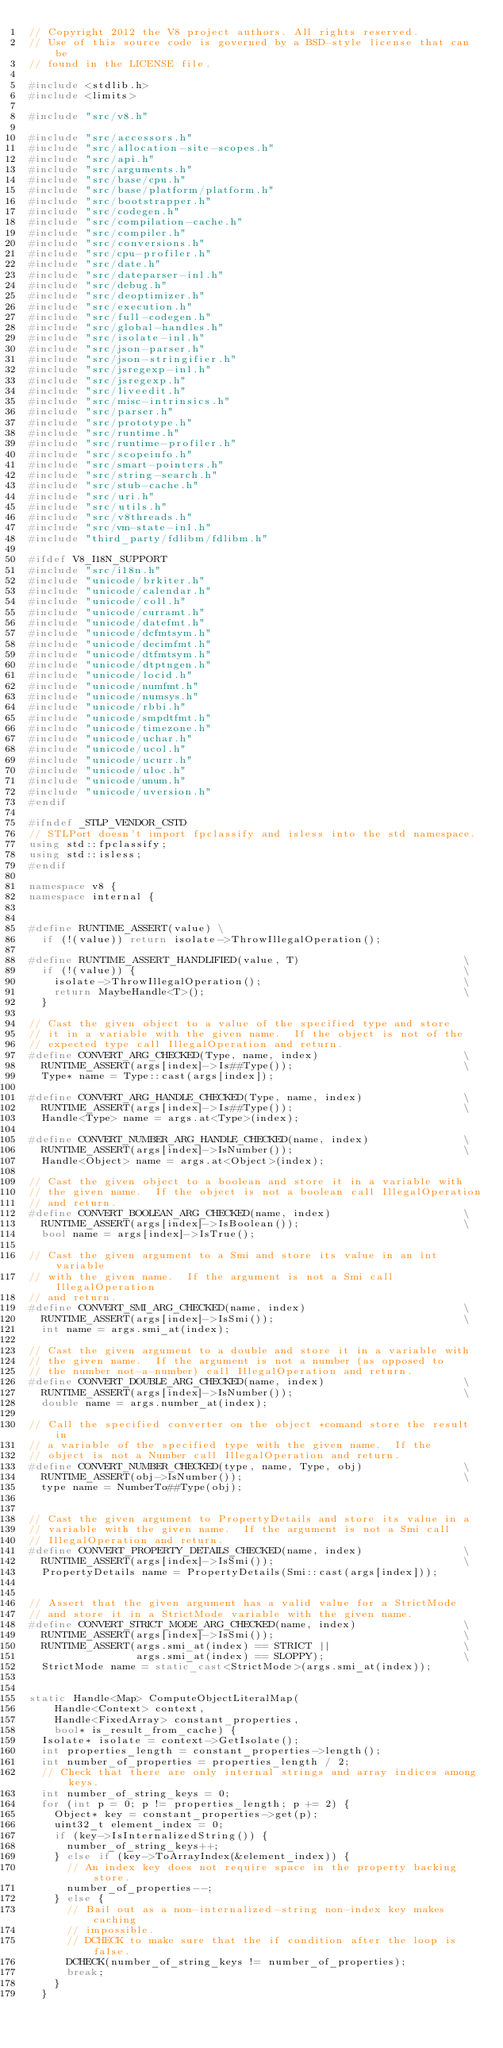<code> <loc_0><loc_0><loc_500><loc_500><_C++_>// Copyright 2012 the V8 project authors. All rights reserved.
// Use of this source code is governed by a BSD-style license that can be
// found in the LICENSE file.

#include <stdlib.h>
#include <limits>

#include "src/v8.h"

#include "src/accessors.h"
#include "src/allocation-site-scopes.h"
#include "src/api.h"
#include "src/arguments.h"
#include "src/base/cpu.h"
#include "src/base/platform/platform.h"
#include "src/bootstrapper.h"
#include "src/codegen.h"
#include "src/compilation-cache.h"
#include "src/compiler.h"
#include "src/conversions.h"
#include "src/cpu-profiler.h"
#include "src/date.h"
#include "src/dateparser-inl.h"
#include "src/debug.h"
#include "src/deoptimizer.h"
#include "src/execution.h"
#include "src/full-codegen.h"
#include "src/global-handles.h"
#include "src/isolate-inl.h"
#include "src/json-parser.h"
#include "src/json-stringifier.h"
#include "src/jsregexp-inl.h"
#include "src/jsregexp.h"
#include "src/liveedit.h"
#include "src/misc-intrinsics.h"
#include "src/parser.h"
#include "src/prototype.h"
#include "src/runtime.h"
#include "src/runtime-profiler.h"
#include "src/scopeinfo.h"
#include "src/smart-pointers.h"
#include "src/string-search.h"
#include "src/stub-cache.h"
#include "src/uri.h"
#include "src/utils.h"
#include "src/v8threads.h"
#include "src/vm-state-inl.h"
#include "third_party/fdlibm/fdlibm.h"

#ifdef V8_I18N_SUPPORT
#include "src/i18n.h"
#include "unicode/brkiter.h"
#include "unicode/calendar.h"
#include "unicode/coll.h"
#include "unicode/curramt.h"
#include "unicode/datefmt.h"
#include "unicode/dcfmtsym.h"
#include "unicode/decimfmt.h"
#include "unicode/dtfmtsym.h"
#include "unicode/dtptngen.h"
#include "unicode/locid.h"
#include "unicode/numfmt.h"
#include "unicode/numsys.h"
#include "unicode/rbbi.h"
#include "unicode/smpdtfmt.h"
#include "unicode/timezone.h"
#include "unicode/uchar.h"
#include "unicode/ucol.h"
#include "unicode/ucurr.h"
#include "unicode/uloc.h"
#include "unicode/unum.h"
#include "unicode/uversion.h"
#endif

#ifndef _STLP_VENDOR_CSTD
// STLPort doesn't import fpclassify and isless into the std namespace.
using std::fpclassify;
using std::isless;
#endif

namespace v8 {
namespace internal {


#define RUNTIME_ASSERT(value) \
  if (!(value)) return isolate->ThrowIllegalOperation();

#define RUNTIME_ASSERT_HANDLIFIED(value, T)                          \
  if (!(value)) {                                                    \
    isolate->ThrowIllegalOperation();                                \
    return MaybeHandle<T>();                                         \
  }

// Cast the given object to a value of the specified type and store
// it in a variable with the given name.  If the object is not of the
// expected type call IllegalOperation and return.
#define CONVERT_ARG_CHECKED(Type, name, index)                       \
  RUNTIME_ASSERT(args[index]->Is##Type());                           \
  Type* name = Type::cast(args[index]);

#define CONVERT_ARG_HANDLE_CHECKED(Type, name, index)                \
  RUNTIME_ASSERT(args[index]->Is##Type());                           \
  Handle<Type> name = args.at<Type>(index);

#define CONVERT_NUMBER_ARG_HANDLE_CHECKED(name, index)               \
  RUNTIME_ASSERT(args[index]->IsNumber());                           \
  Handle<Object> name = args.at<Object>(index);

// Cast the given object to a boolean and store it in a variable with
// the given name.  If the object is not a boolean call IllegalOperation
// and return.
#define CONVERT_BOOLEAN_ARG_CHECKED(name, index)                     \
  RUNTIME_ASSERT(args[index]->IsBoolean());                          \
  bool name = args[index]->IsTrue();

// Cast the given argument to a Smi and store its value in an int variable
// with the given name.  If the argument is not a Smi call IllegalOperation
// and return.
#define CONVERT_SMI_ARG_CHECKED(name, index)                         \
  RUNTIME_ASSERT(args[index]->IsSmi());                              \
  int name = args.smi_at(index);

// Cast the given argument to a double and store it in a variable with
// the given name.  If the argument is not a number (as opposed to
// the number not-a-number) call IllegalOperation and return.
#define CONVERT_DOUBLE_ARG_CHECKED(name, index)                      \
  RUNTIME_ASSERT(args[index]->IsNumber());                           \
  double name = args.number_at(index);

// Call the specified converter on the object *comand store the result in
// a variable of the specified type with the given name.  If the
// object is not a Number call IllegalOperation and return.
#define CONVERT_NUMBER_CHECKED(type, name, Type, obj)                \
  RUNTIME_ASSERT(obj->IsNumber());                                   \
  type name = NumberTo##Type(obj);


// Cast the given argument to PropertyDetails and store its value in a
// variable with the given name.  If the argument is not a Smi call
// IllegalOperation and return.
#define CONVERT_PROPERTY_DETAILS_CHECKED(name, index)                \
  RUNTIME_ASSERT(args[index]->IsSmi());                              \
  PropertyDetails name = PropertyDetails(Smi::cast(args[index]));


// Assert that the given argument has a valid value for a StrictMode
// and store it in a StrictMode variable with the given name.
#define CONVERT_STRICT_MODE_ARG_CHECKED(name, index)                 \
  RUNTIME_ASSERT(args[index]->IsSmi());                              \
  RUNTIME_ASSERT(args.smi_at(index) == STRICT ||                     \
                 args.smi_at(index) == SLOPPY);                      \
  StrictMode name = static_cast<StrictMode>(args.smi_at(index));


static Handle<Map> ComputeObjectLiteralMap(
    Handle<Context> context,
    Handle<FixedArray> constant_properties,
    bool* is_result_from_cache) {
  Isolate* isolate = context->GetIsolate();
  int properties_length = constant_properties->length();
  int number_of_properties = properties_length / 2;
  // Check that there are only internal strings and array indices among keys.
  int number_of_string_keys = 0;
  for (int p = 0; p != properties_length; p += 2) {
    Object* key = constant_properties->get(p);
    uint32_t element_index = 0;
    if (key->IsInternalizedString()) {
      number_of_string_keys++;
    } else if (key->ToArrayIndex(&element_index)) {
      // An index key does not require space in the property backing store.
      number_of_properties--;
    } else {
      // Bail out as a non-internalized-string non-index key makes caching
      // impossible.
      // DCHECK to make sure that the if condition after the loop is false.
      DCHECK(number_of_string_keys != number_of_properties);
      break;
    }
  }</code> 